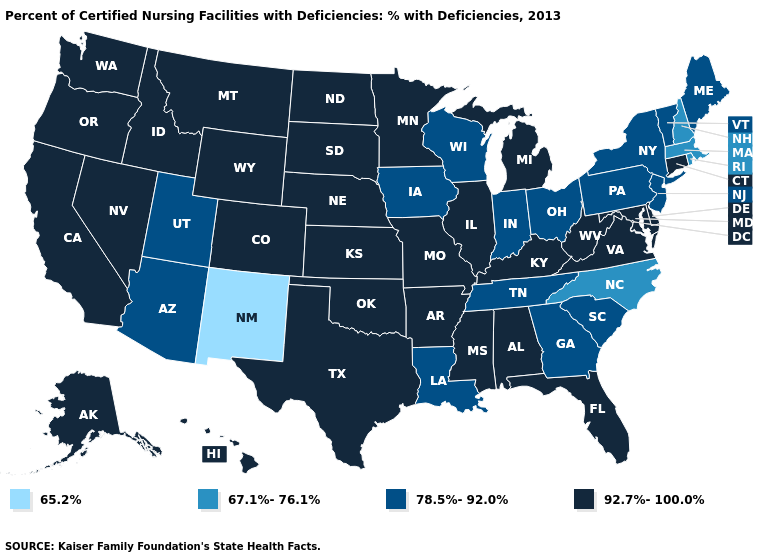What is the value of Kentucky?
Write a very short answer. 92.7%-100.0%. Which states hav the highest value in the West?
Short answer required. Alaska, California, Colorado, Hawaii, Idaho, Montana, Nevada, Oregon, Washington, Wyoming. What is the value of Maine?
Quick response, please. 78.5%-92.0%. What is the highest value in the USA?
Answer briefly. 92.7%-100.0%. Name the states that have a value in the range 67.1%-76.1%?
Quick response, please. Massachusetts, New Hampshire, North Carolina, Rhode Island. What is the lowest value in states that border New Mexico?
Give a very brief answer. 78.5%-92.0%. Does the map have missing data?
Concise answer only. No. Among the states that border Arkansas , which have the highest value?
Write a very short answer. Mississippi, Missouri, Oklahoma, Texas. What is the value of Indiana?
Be succinct. 78.5%-92.0%. What is the lowest value in states that border Delaware?
Keep it brief. 78.5%-92.0%. Name the states that have a value in the range 92.7%-100.0%?
Answer briefly. Alabama, Alaska, Arkansas, California, Colorado, Connecticut, Delaware, Florida, Hawaii, Idaho, Illinois, Kansas, Kentucky, Maryland, Michigan, Minnesota, Mississippi, Missouri, Montana, Nebraska, Nevada, North Dakota, Oklahoma, Oregon, South Dakota, Texas, Virginia, Washington, West Virginia, Wyoming. Does New Mexico have the lowest value in the USA?
Keep it brief. Yes. Does North Carolina have the highest value in the USA?
Give a very brief answer. No. Which states have the highest value in the USA?
Short answer required. Alabama, Alaska, Arkansas, California, Colorado, Connecticut, Delaware, Florida, Hawaii, Idaho, Illinois, Kansas, Kentucky, Maryland, Michigan, Minnesota, Mississippi, Missouri, Montana, Nebraska, Nevada, North Dakota, Oklahoma, Oregon, South Dakota, Texas, Virginia, Washington, West Virginia, Wyoming. What is the lowest value in states that border Maryland?
Keep it brief. 78.5%-92.0%. 